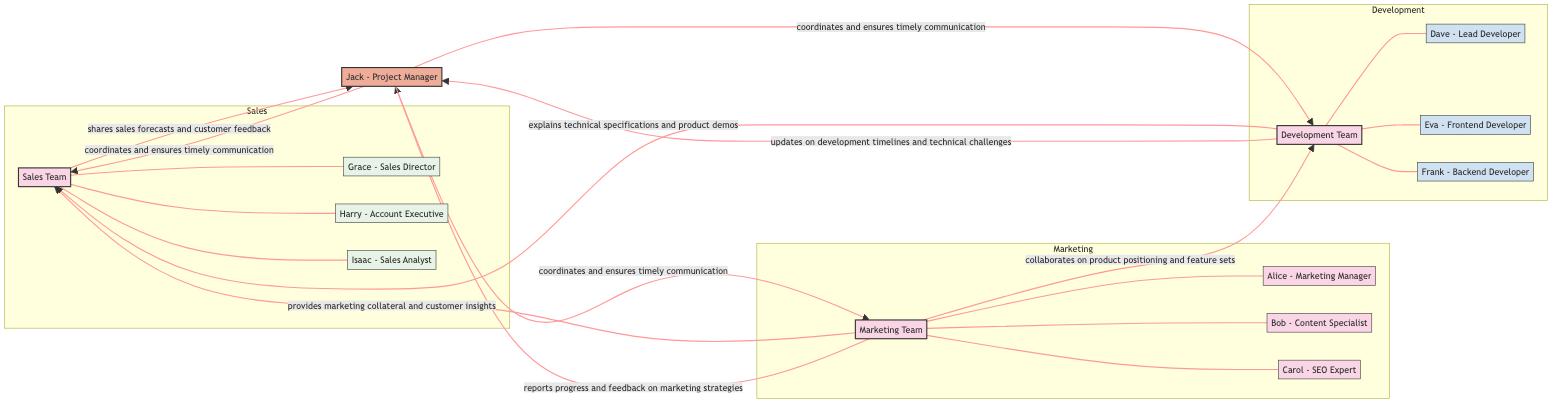What are the departments involved in the product launch? The diagram includes three departments: Marketing Team, Development Team, and Sales Team. These teams are represented as distinct nodes in the network.
Answer: Marketing Team, Development Team, Sales Team How many members are in the Marketing Team? The Marketing Team node lists three members: Alice, Bob, and Carol. Counting these members gives the total.
Answer: 3 What is the relationship between the Marketing Team and the Sales Team? The diagram includes an edge that indicates the Marketing Team provides marketing collateral and customer insights to the Sales Team. This is the explicit relationship shown between the two nodes.
Answer: provides marketing collateral and customer insights Who does the Project Manager report to? The Project Manager node connects to all teams, indicating that Jack the Project Manager coordinates and ensures timely communication with each team. This shows he reports to each department.
Answer: all teams How many connections does the Development Team have with other nodes? The Development Team node connects to the Sales Team, Marketing Team, and Project Manager, totaling three edges that represent its relationships with other teams.
Answer: 3 What is the specific role of the individual in the Project Manager node? The diagram identifies the individual in the Project Manager node specifically as Jack - Project Manager, indicating both his name and role within the team structure.
Answer: Jack - Project Manager How does the Development Team communicate with the Sales Team? The connection between the Development Team and the Sales Team indicates that the Development Team explains technical specifications and product demos to the Sales Team, showcasing the nature of their communication.
Answer: explains technical specifications and product demos Which individual connects all three teams? The Project Manager node (Jack) is the individual who coordinates and ensures communication between the Marketing Team, Development Team, and Sales Team, acting as a central figure in the communication flow.
Answer: Jack - Project Manager What is the primary role of the Marketing Team in this project? The Marketing Team's primary role as shown in the diagram is to collaborate on product positioning and feature sets; it also provides collateral and insights to Sales. This indicates their involvement in several critical aspects of the project.
Answer: collaborates on product positioning and feature sets 